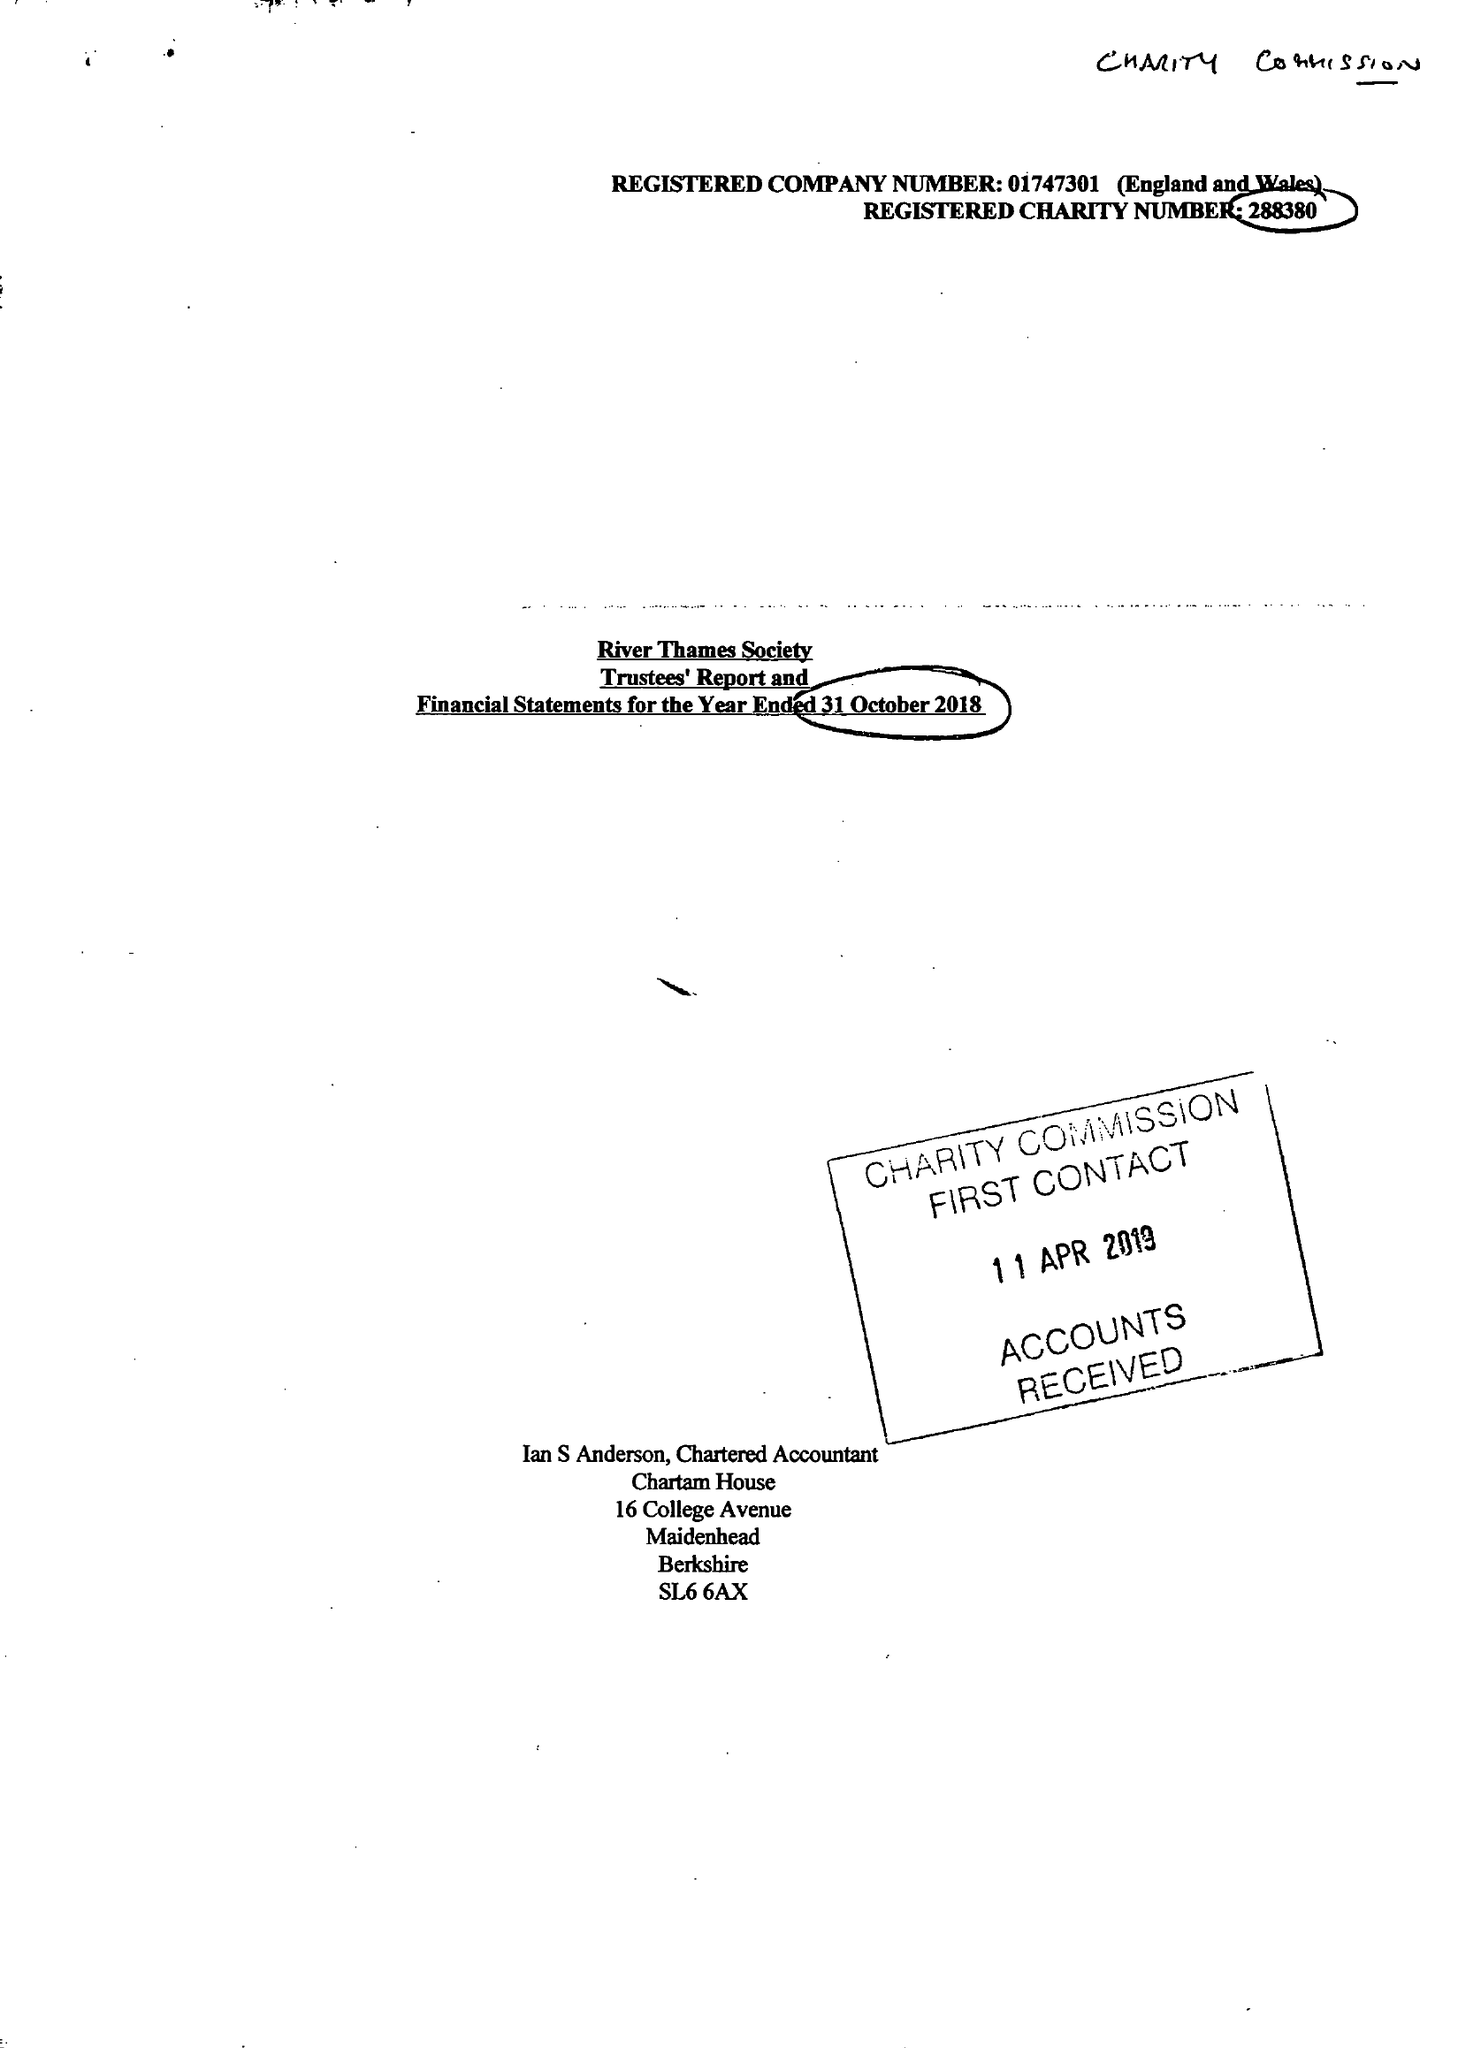What is the value for the charity_number?
Answer the question using a single word or phrase. 288380 